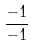Convert formula to latex. <formula><loc_0><loc_0><loc_500><loc_500>\frac { - 1 } { - 1 }</formula> 